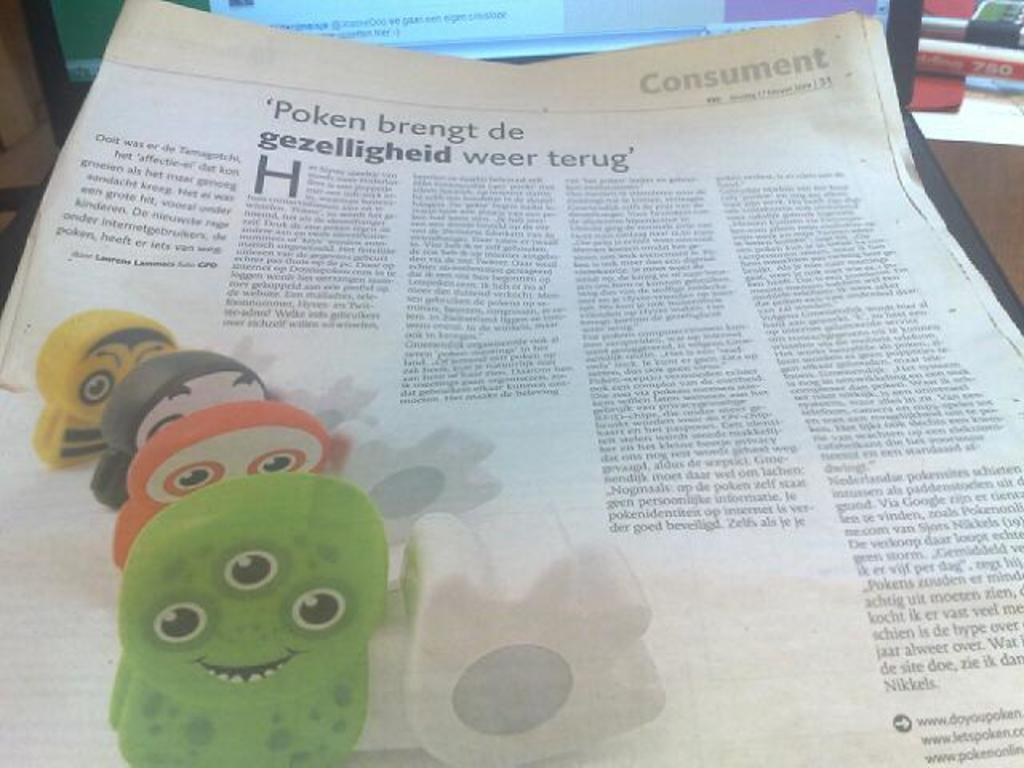What is the main object in the image? There is a paper in the image. What electronic device is also visible in the image? There is a laptop in the image. What is the color of the surface on which the objects are placed? The objects are on a brown color surface. What color is the background of the image? The background of the image is green. How much does the brain weigh in the image? There is no brain present in the image, so it is not possible to determine its weight. 